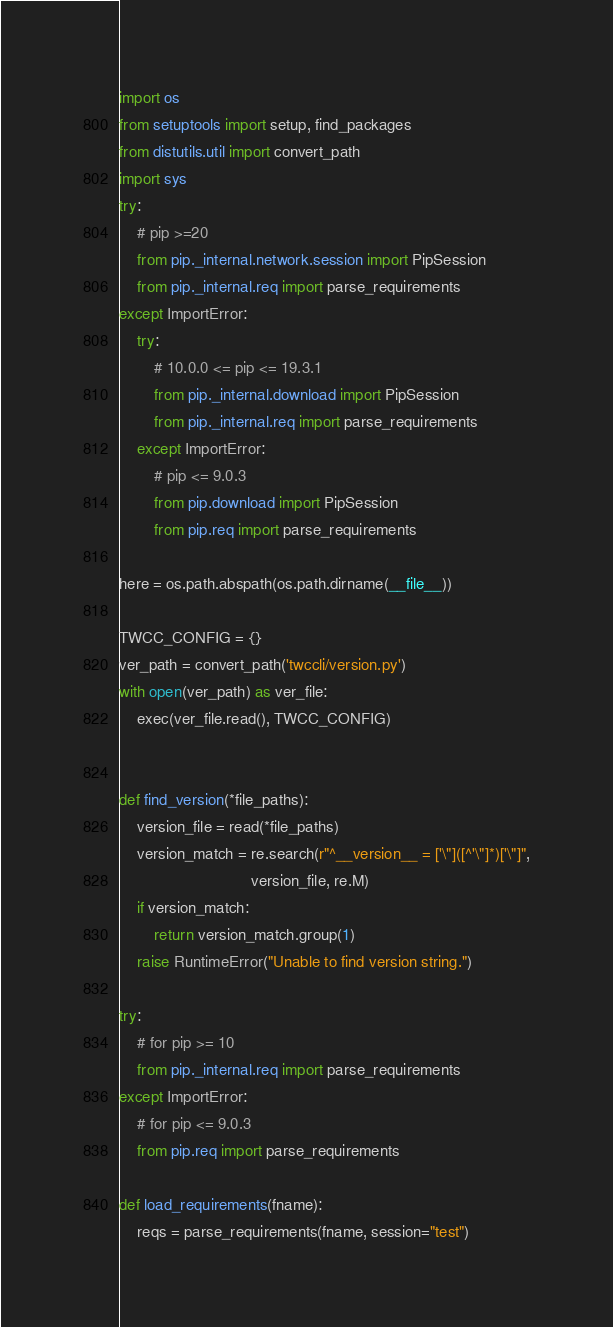Convert code to text. <code><loc_0><loc_0><loc_500><loc_500><_Python_>import os
from setuptools import setup, find_packages
from distutils.util import convert_path
import sys
try:
    # pip >=20
    from pip._internal.network.session import PipSession
    from pip._internal.req import parse_requirements
except ImportError:
    try:
        # 10.0.0 <= pip <= 19.3.1
        from pip._internal.download import PipSession
        from pip._internal.req import parse_requirements
    except ImportError:
        # pip <= 9.0.3
        from pip.download import PipSession
        from pip.req import parse_requirements

here = os.path.abspath(os.path.dirname(__file__))

TWCC_CONFIG = {}
ver_path = convert_path('twccli/version.py')
with open(ver_path) as ver_file:
    exec(ver_file.read(), TWCC_CONFIG)


def find_version(*file_paths):
    version_file = read(*file_paths)
    version_match = re.search(r"^__version__ = ['\"]([^'\"]*)['\"]",
                              version_file, re.M)
    if version_match:
        return version_match.group(1)
    raise RuntimeError("Unable to find version string.")

try:
    # for pip >= 10
    from pip._internal.req import parse_requirements
except ImportError:
    # for pip <= 9.0.3
    from pip.req import parse_requirements

def load_requirements(fname):
    reqs = parse_requirements(fname, session="test")</code> 